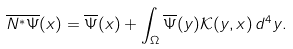<formula> <loc_0><loc_0><loc_500><loc_500>\overline { N ^ { * } \Psi } ( x ) = \overline { \Psi } ( x ) + \int _ { \Omega } \overline { \Psi } ( y ) \mathcal { K } ( y , x ) \, d ^ { 4 } y .</formula> 